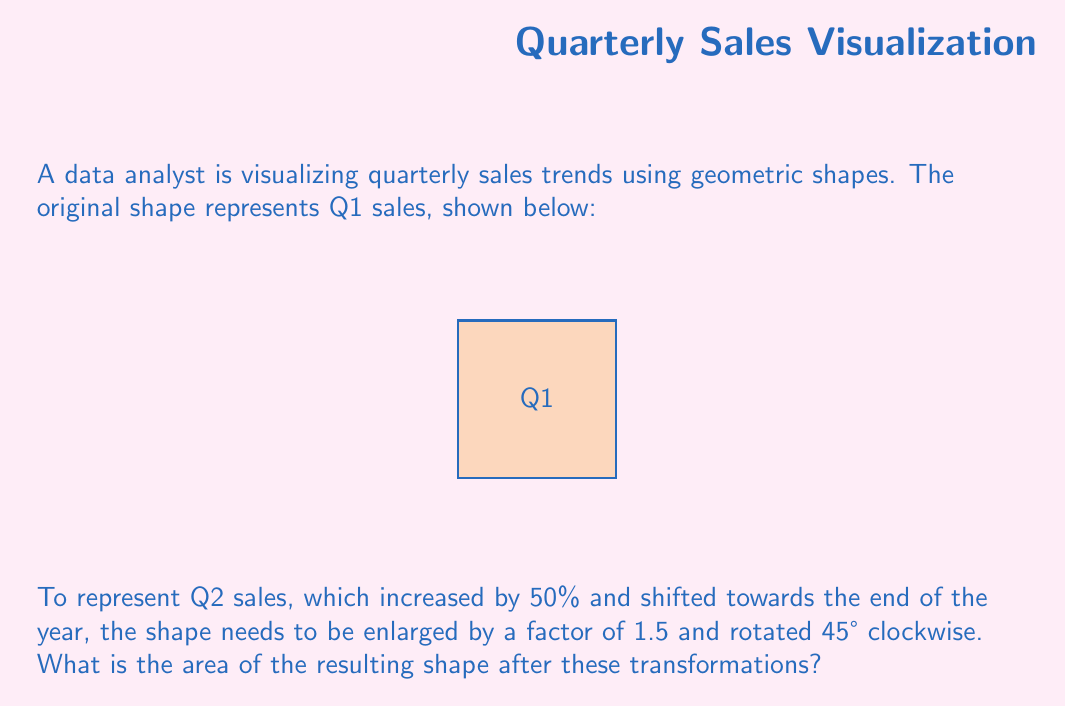Can you solve this math problem? Let's approach this step-by-step:

1) The original shape is a square. Let's calculate its area:
   Side length = 2 units
   Area = $2^2 = 4$ square units

2) For Q2, we need to enlarge the shape by a factor of 1.5:
   New side length = $2 * 1.5 = 3$ units
   New area before rotation = $3^2 = 9$ square units

3) Rotation doesn't change the area of a shape. So, even after rotating 45° clockwise, the area remains the same.

4) Therefore, the final area after both transformations is 9 square units.

Note: For non-native English speakers learning data analysis, it's important to understand that geometric transformations can be used to represent data trends visually. In this case:
- The enlargement represents the 50% increase in sales.
- The rotation represents the shift towards the end of the year.

These visual representations can make data trends more intuitive and easier to understand for audiences.
Answer: 9 square units 